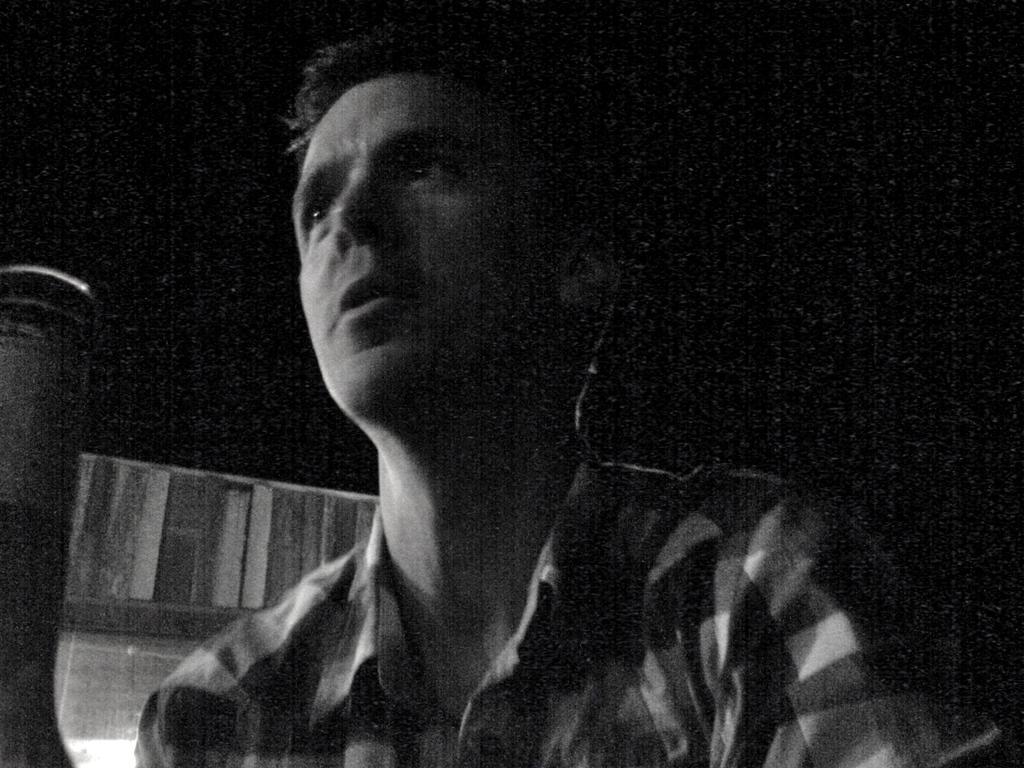Describe this image in one or two sentences. In this picture there is a man holding the glass. At the back it looks like a door and there is a black background. 